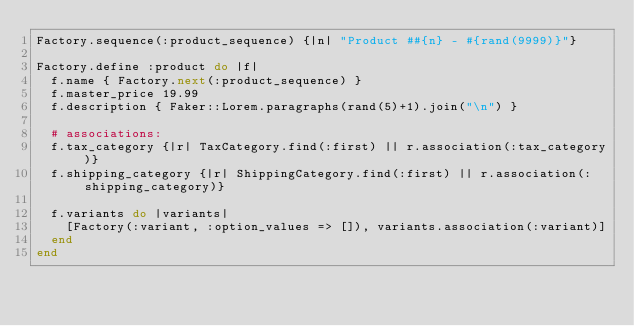<code> <loc_0><loc_0><loc_500><loc_500><_Ruby_>Factory.sequence(:product_sequence) {|n| "Product ##{n} - #{rand(9999)}"}

Factory.define :product do |f|
  f.name { Factory.next(:product_sequence) }
  f.master_price 19.99
  f.description { Faker::Lorem.paragraphs(rand(5)+1).join("\n") }

  # associations:
  f.tax_category {|r| TaxCategory.find(:first) || r.association(:tax_category)}
  f.shipping_category {|r| ShippingCategory.find(:first) || r.association(:shipping_category)}
  
  f.variants do |variants|
    [Factory(:variant, :option_values => []), variants.association(:variant)]
  end
end</code> 